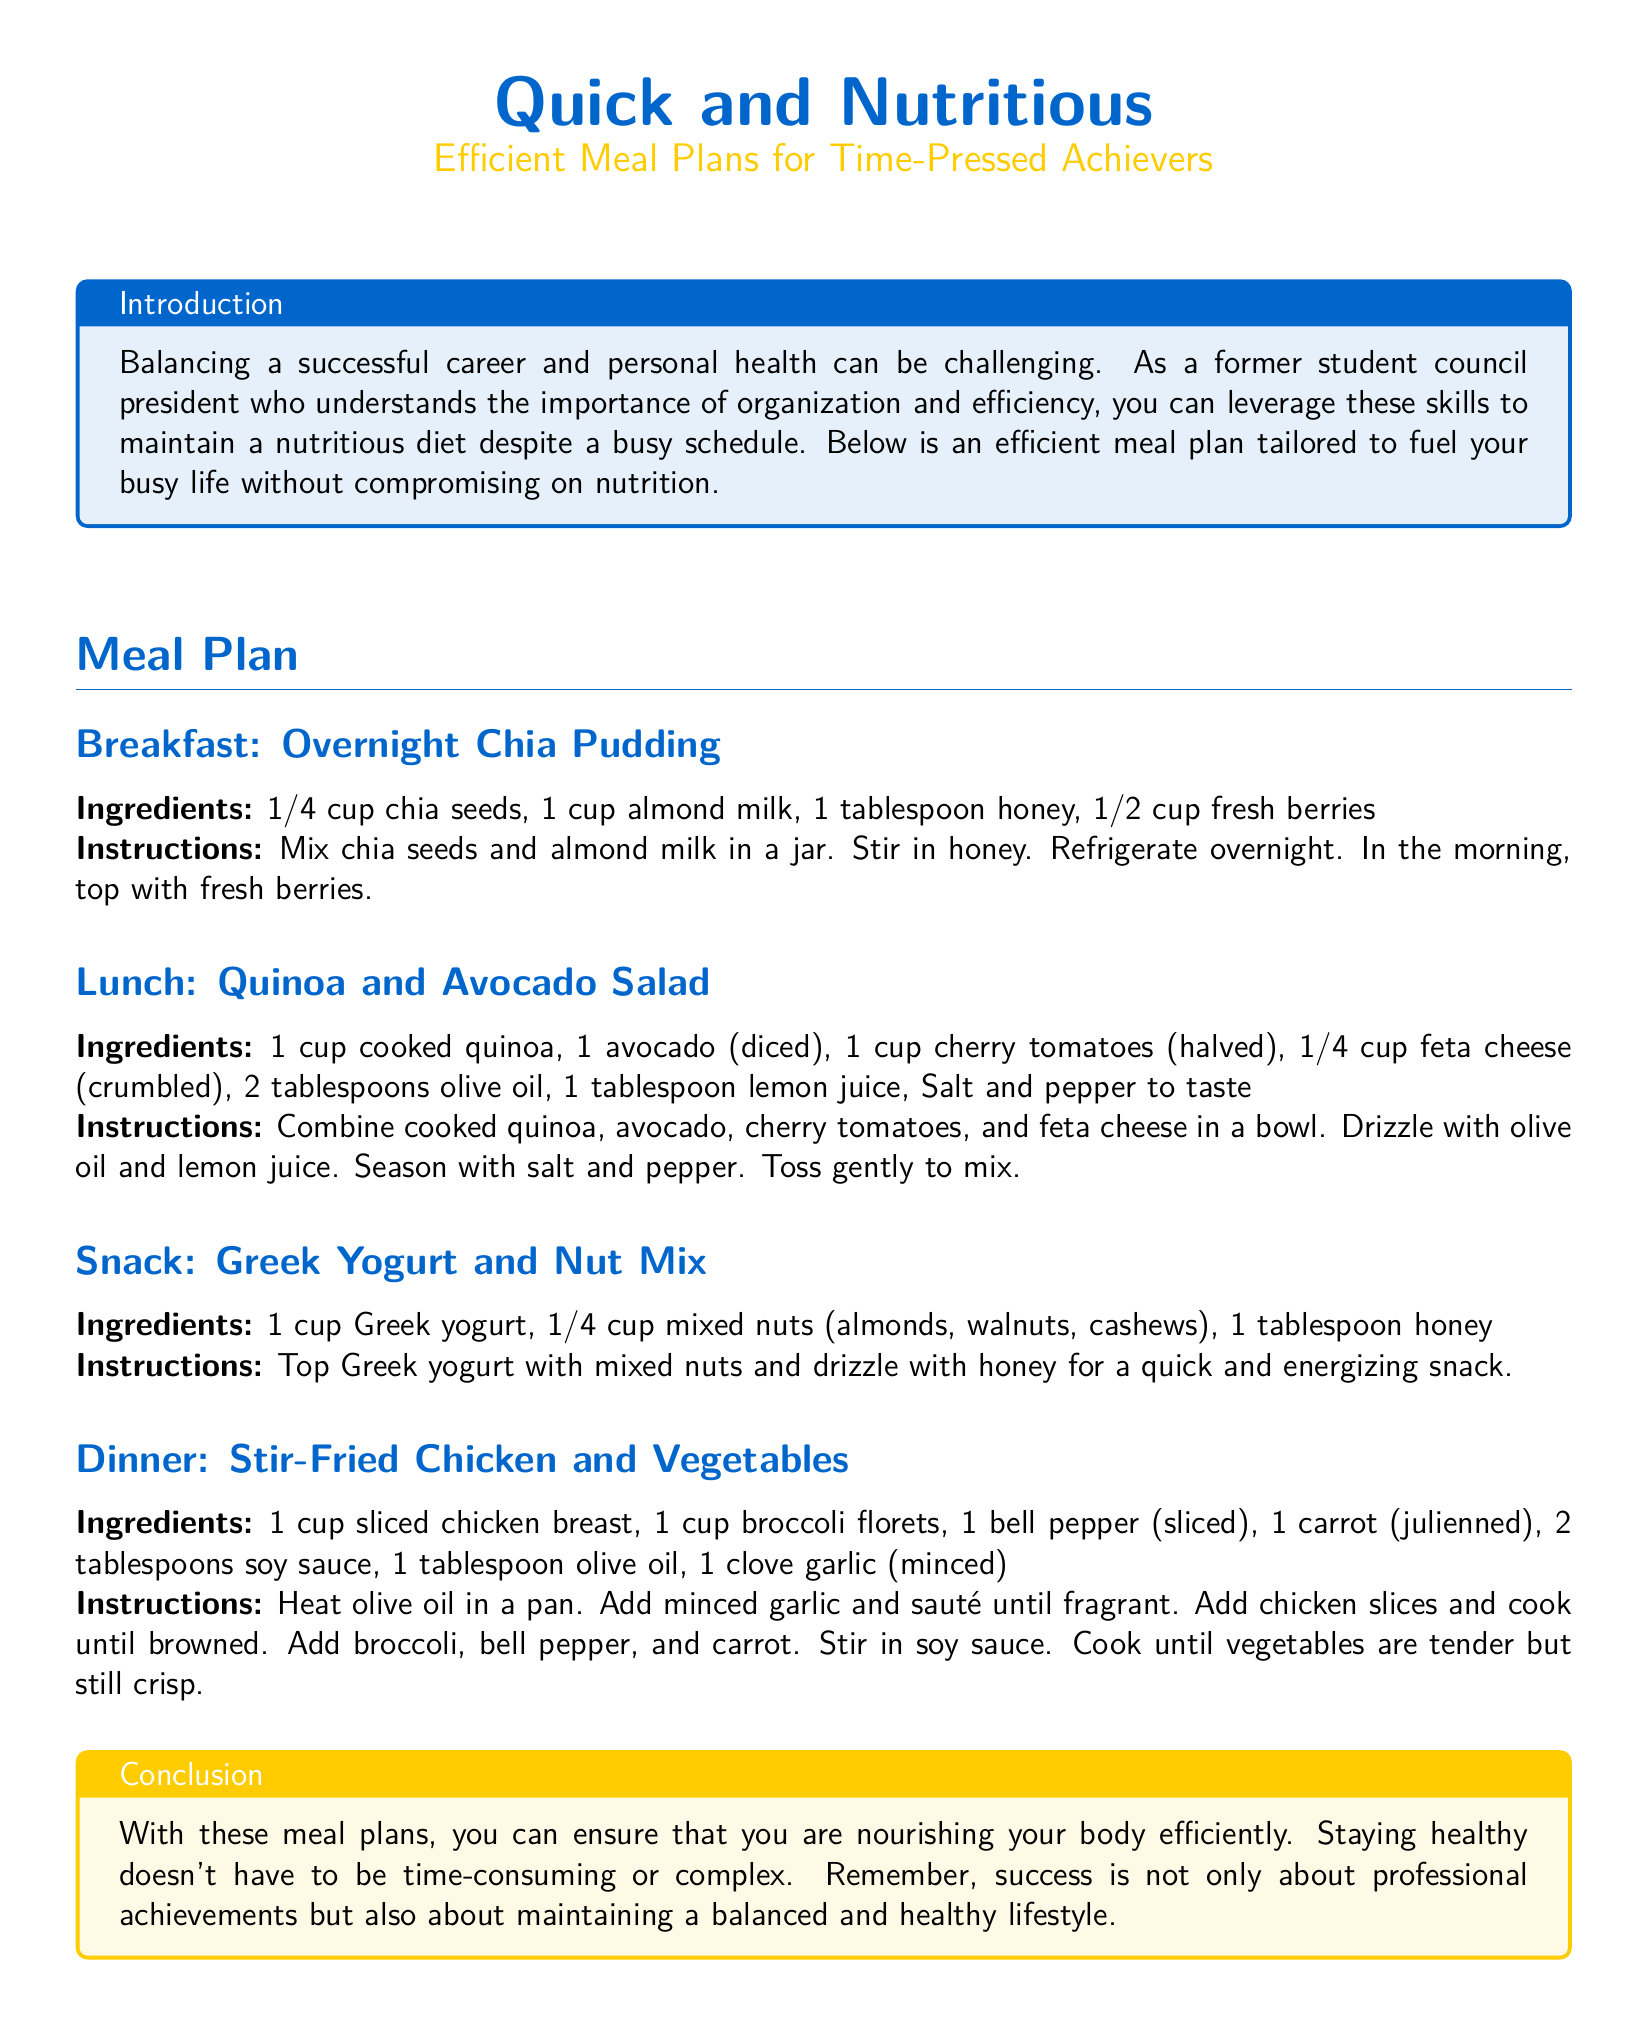What is the first meal listed in the plan? The first meal listed is Overnight Chia Pudding.
Answer: Overnight Chia Pudding How many tablespoons of olive oil are needed for the lunch salad? The lunch salad requires 2 tablespoons of olive oil.
Answer: 2 tablespoons What is the main protein source in the dinner recipe? The main protein source in the dinner recipe is sliced chicken breast.
Answer: sliced chicken breast What is the serving suggestion for the Greek yogurt snack? The Greek yogurt snack suggests topping the yogurt with mixed nuts and honey.
Answer: topped with mixed nuts and honey What type of milk is used in the breakfast recipe? The type of milk used in the breakfast recipe is almond milk.
Answer: almond milk How many ingredients are listed for the dinner meal? There are 7 ingredients listed for the dinner meal.
Answer: 7 ingredients What type of cheese is included in the lunch salad? The type of cheese included in the lunch salad is feta cheese.
Answer: feta cheese What is emphasized in the conclusion of the document? The conclusion emphasizes maintaining a balanced and healthy lifestyle.
Answer: balanced and healthy lifestyle 